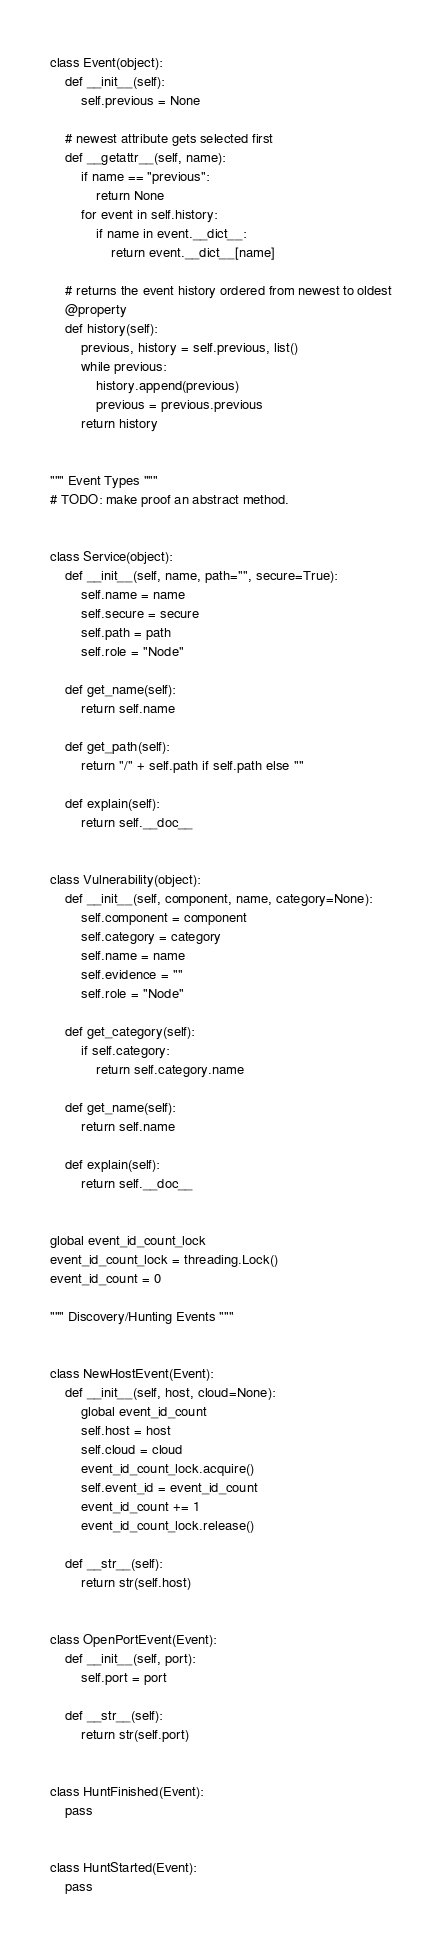Convert code to text. <code><loc_0><loc_0><loc_500><loc_500><_Python_>
class Event(object):
    def __init__(self):
        self.previous = None

    # newest attribute gets selected first
    def __getattr__(self, name):
        if name == "previous":
            return None
        for event in self.history:
            if name in event.__dict__:
                return event.__dict__[name]

    # returns the event history ordered from newest to oldest
    @property
    def history(self):
        previous, history = self.previous, list()
        while previous:
            history.append(previous)
            previous = previous.previous
        return history


""" Event Types """
# TODO: make proof an abstract method.


class Service(object):
    def __init__(self, name, path="", secure=True):
        self.name = name
        self.secure = secure
        self.path = path
        self.role = "Node"

    def get_name(self):
        return self.name

    def get_path(self):
        return "/" + self.path if self.path else ""

    def explain(self):
        return self.__doc__


class Vulnerability(object):
    def __init__(self, component, name, category=None):
        self.component = component
        self.category = category
        self.name = name
        self.evidence = ""
        self.role = "Node"

    def get_category(self):
        if self.category:
            return self.category.name

    def get_name(self):
        return self.name

    def explain(self):
        return self.__doc__


global event_id_count_lock
event_id_count_lock = threading.Lock()
event_id_count = 0

""" Discovery/Hunting Events """


class NewHostEvent(Event):
    def __init__(self, host, cloud=None):
        global event_id_count
        self.host = host
        self.cloud = cloud
        event_id_count_lock.acquire()
        self.event_id = event_id_count
        event_id_count += 1
        event_id_count_lock.release()

    def __str__(self):
        return str(self.host)


class OpenPortEvent(Event):
    def __init__(self, port):
        self.port = port
    
    def __str__(self):
        return str(self.port)


class HuntFinished(Event):
    pass


class HuntStarted(Event):
    pass
</code> 